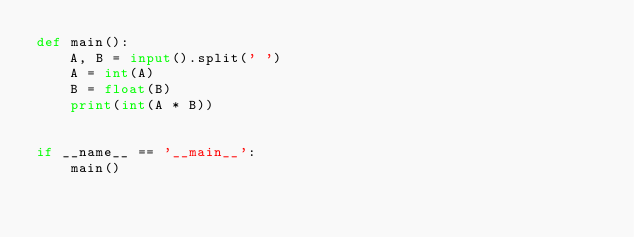Convert code to text. <code><loc_0><loc_0><loc_500><loc_500><_Python_>def main():
    A, B = input().split(' ')
    A = int(A)
    B = float(B)
    print(int(A * B))


if __name__ == '__main__':
    main()</code> 